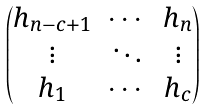Convert formula to latex. <formula><loc_0><loc_0><loc_500><loc_500>\begin{pmatrix} h _ { n - c + 1 } & \cdots & h _ { n } \\ \vdots & \ddots & \vdots \\ h _ { 1 } & \cdots & h _ { c } \end{pmatrix}</formula> 